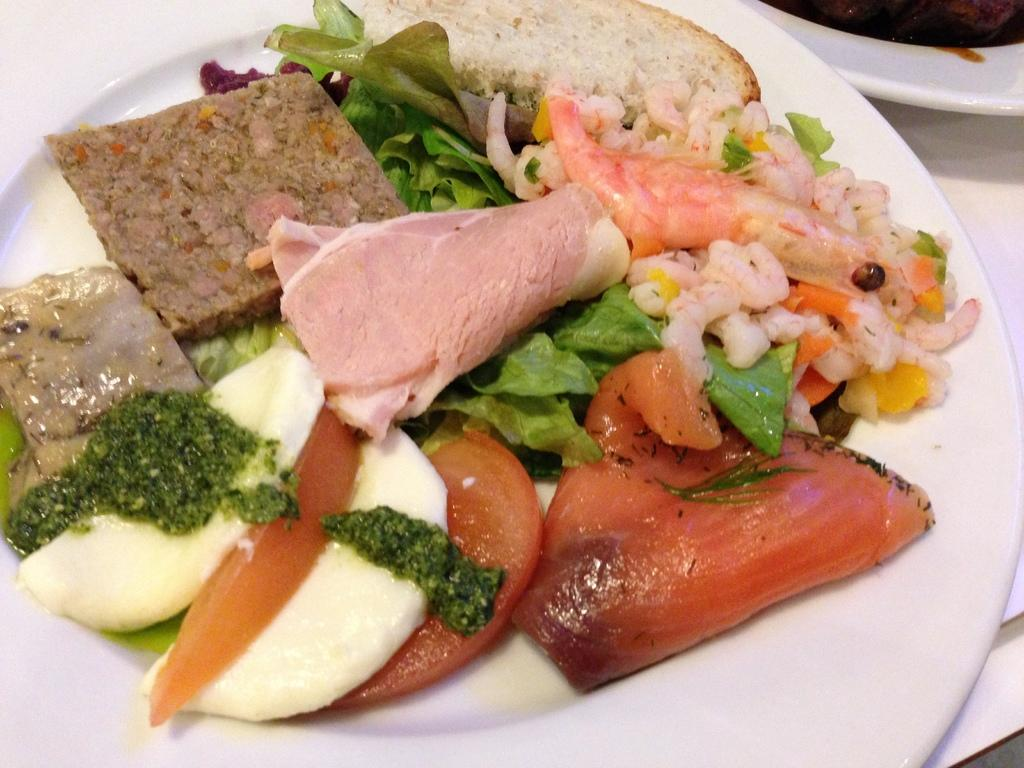What piece of furniture is present in the image? There is a table in the image. How many plates are on the table? There are two plates on the table. What is on one of the plates? There is a salad on one of the plates. What is on the other plate? There is a food item on the other plate. What type of secretary is sitting next to the table in the image? There is no secretary present in the image; it only features a table with two plates. What is the texture of the milk on the table in the image? There is no milk present in the image, so its texture cannot be determined. 